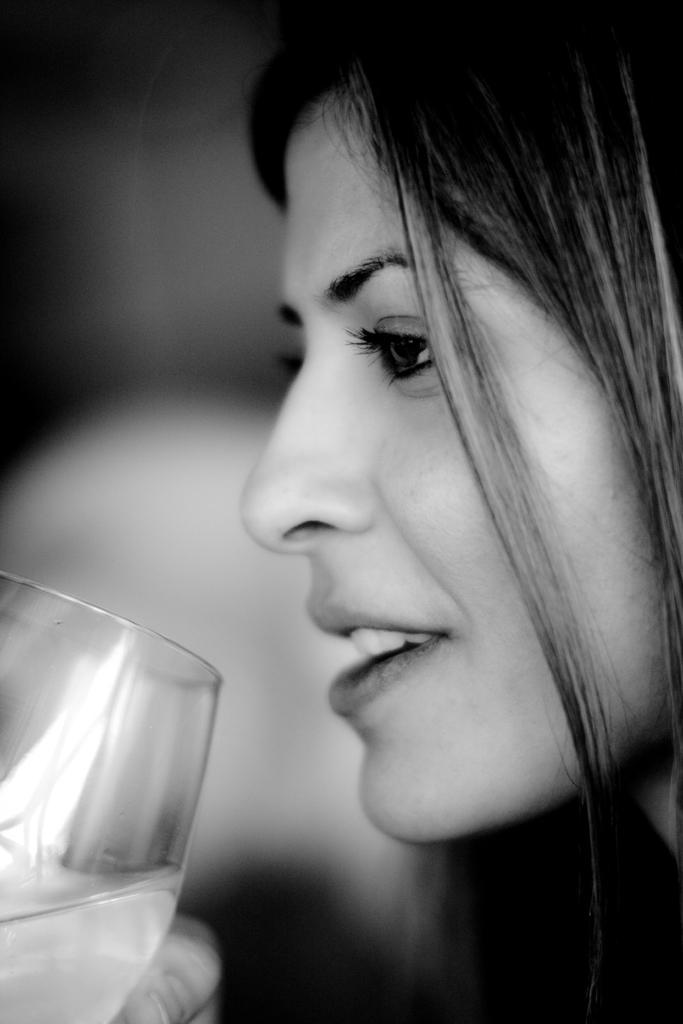Please provide a concise description of this image. As we can see in the image there is a woman holding glass. 